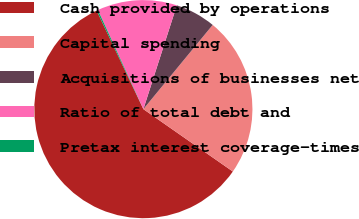Convert chart. <chart><loc_0><loc_0><loc_500><loc_500><pie_chart><fcel>Cash provided by operations<fcel>Capital spending<fcel>Acquisitions of businesses net<fcel>Ratio of total debt and<fcel>Pretax interest coverage-times<nl><fcel>58.26%<fcel>23.73%<fcel>6.0%<fcel>11.81%<fcel>0.2%<nl></chart> 